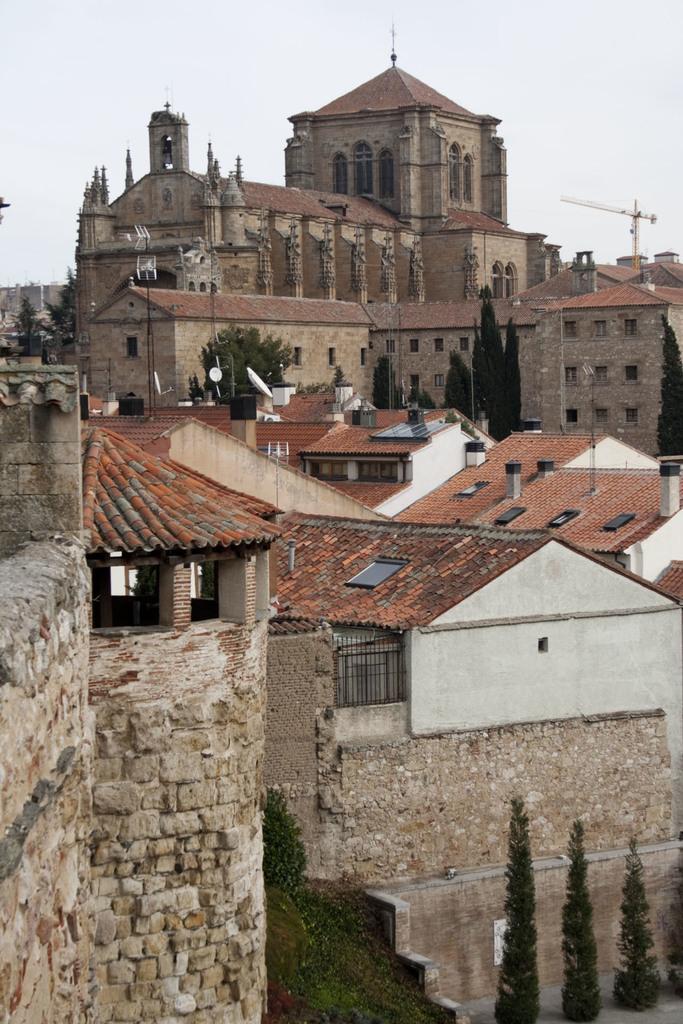How would you summarize this image in a sentence or two? In this picture I can see few buildings and trees in the middle, at the top there is the sky. 